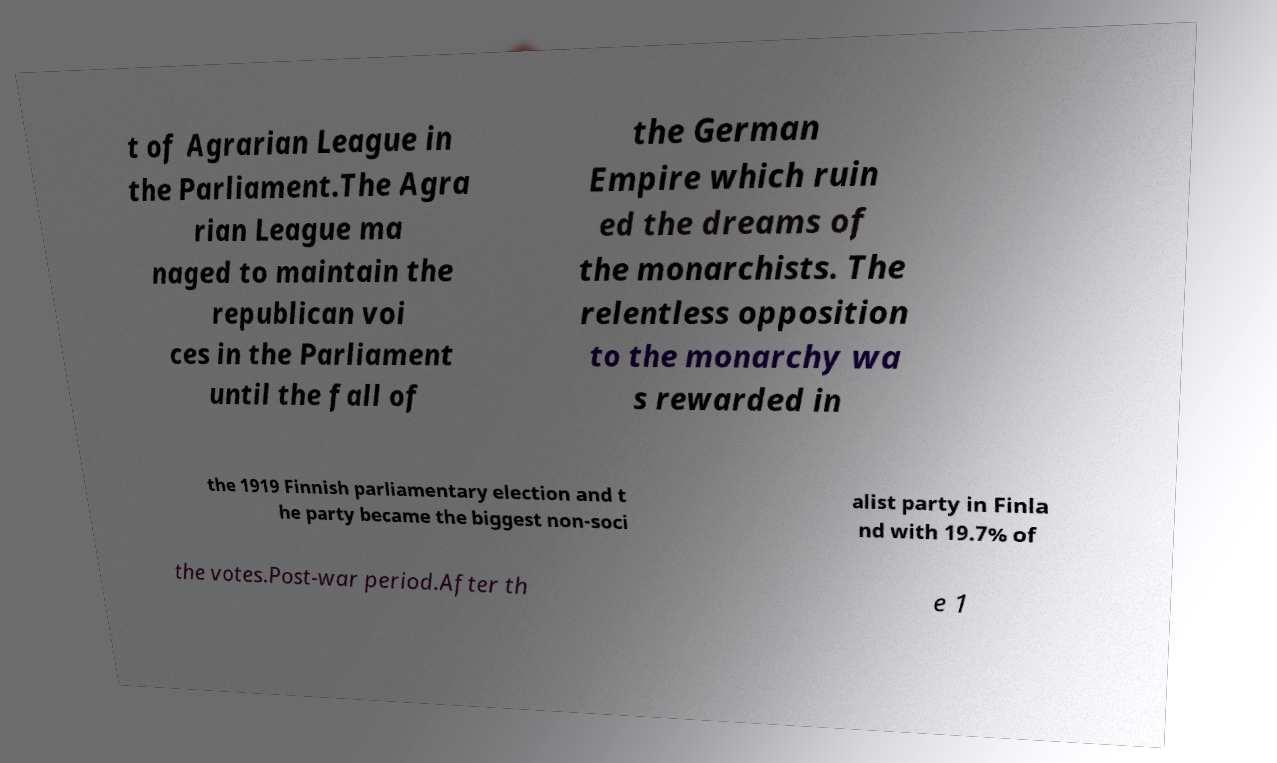Please read and relay the text visible in this image. What does it say? t of Agrarian League in the Parliament.The Agra rian League ma naged to maintain the republican voi ces in the Parliament until the fall of the German Empire which ruin ed the dreams of the monarchists. The relentless opposition to the monarchy wa s rewarded in the 1919 Finnish parliamentary election and t he party became the biggest non-soci alist party in Finla nd with 19.7% of the votes.Post-war period.After th e 1 